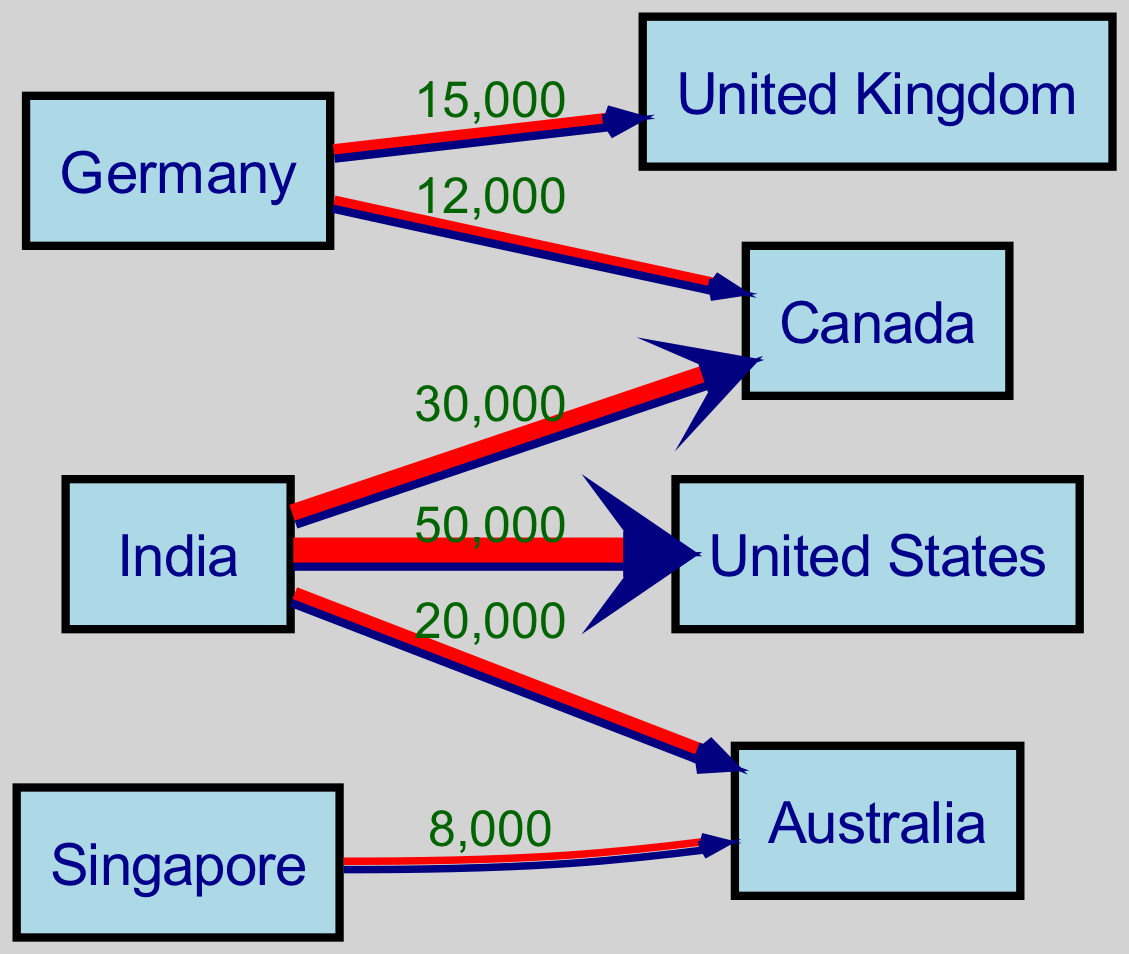What is the total migration flow from India to the United States? The diagram shows a direct flow from India to the United States with a value of 50,000, making it the total migration flow from India to this destination.
Answer: 50,000 Which country receives the second-highest number of skilled migrants from India? India has flows to Canada (30,000) and Australia (20,000). Comparing these, Canada has the higher flow, thus it receives the second-highest skilled migrants from India.
Answer: Canada How many nodes are shown in the diagram? The diagram depicts the origin and destination countries as nodes, totaling 7 distinct nodes: India, Canada, Germany, Australia, United States, United Kingdom, and Singapore. Hence, the total number of nodes is 7.
Answer: 7 What is the migration flow from Germany to Canada? The diagram represents a migration flow from Germany to Canada with a value of 12,000, indicating the number of skilled workers moving in that direction.
Answer: 12,000 Which destination has the least migration flow from any country in the diagram? Among the flows depicted, the least amount is 8,000 from Singapore to Australia, thus this is the smallest migration flow in the diagram.
Answer: Australia What is the total migration flow from India? When summing the flows from India: 50,000 (to the United States) + 30,000 (to Canada) + 20,000 (to Australia), we arrive at a total migration flow from India of 100,000 skilled workers.
Answer: 100,000 Which two countries have the highest combined migration flow into Canada? Canada receives migrants from India (30,000) and Germany (12,000). The combined migration flow into Canada thus amounts to 42,000.
Answer: 42,000 What is the only country that exports skilled workers to Australia according to the diagram? From the displayed flows, Singapore is the only country sending skilled workers to Australia with a flow value of 8,000, making it the sole exporter to that destination.
Answer: Singapore 